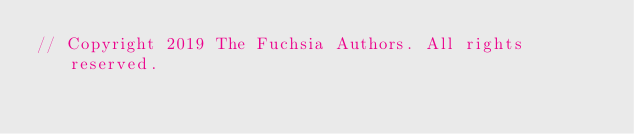<code> <loc_0><loc_0><loc_500><loc_500><_Rust_>// Copyright 2019 The Fuchsia Authors. All rights reserved.</code> 